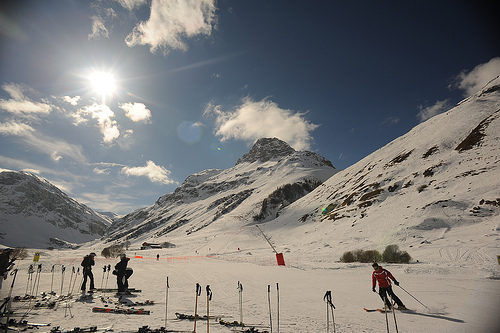Are there any cars or bulbs? There are no cars or bulbs visible in the scene, which is predominantly dominated by snowy landscapes and skiing activities. 